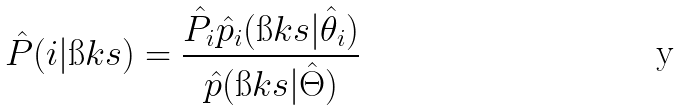<formula> <loc_0><loc_0><loc_500><loc_500>\hat { P } ( i | \i k s ) = \frac { \hat { P } _ { i } \hat { p } _ { i } ( \i k s | \hat { \theta } _ { i } ) } { \hat { p } ( \i k s | \hat { \Theta } ) }</formula> 